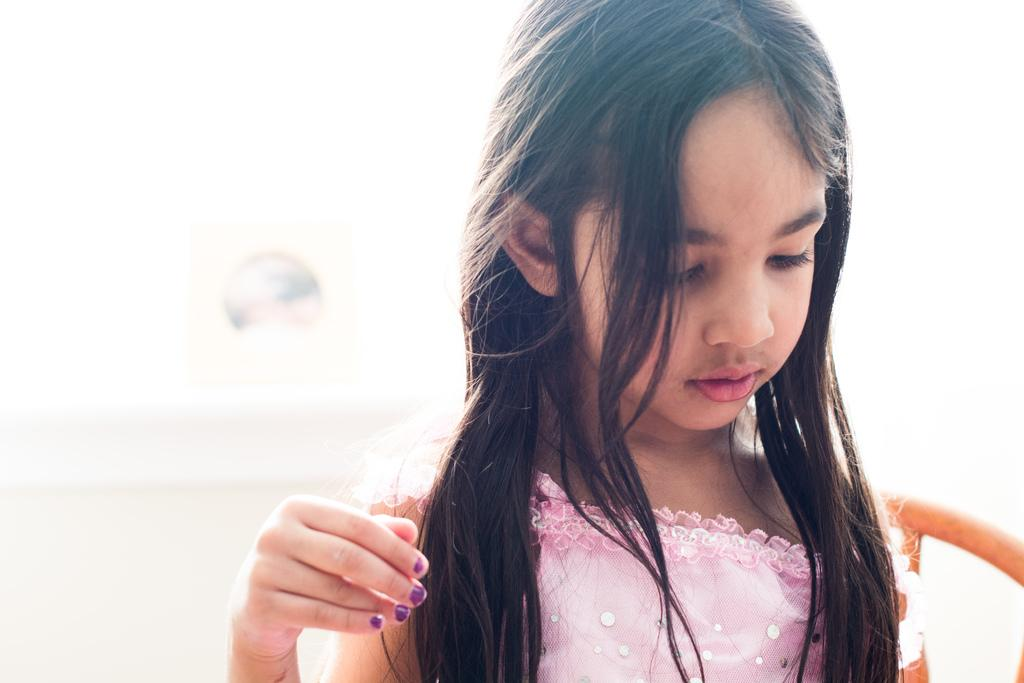Who is the main subject in the image? There is a small girl in the image. What is the girl doing in the image? The girl is looking down. Can you describe the background of the image? The background of the image is blurred. What type of sound can be heard coming from the lettuce in the image? There is no lettuce present in the image, and therefore no sound can be heard from it. 